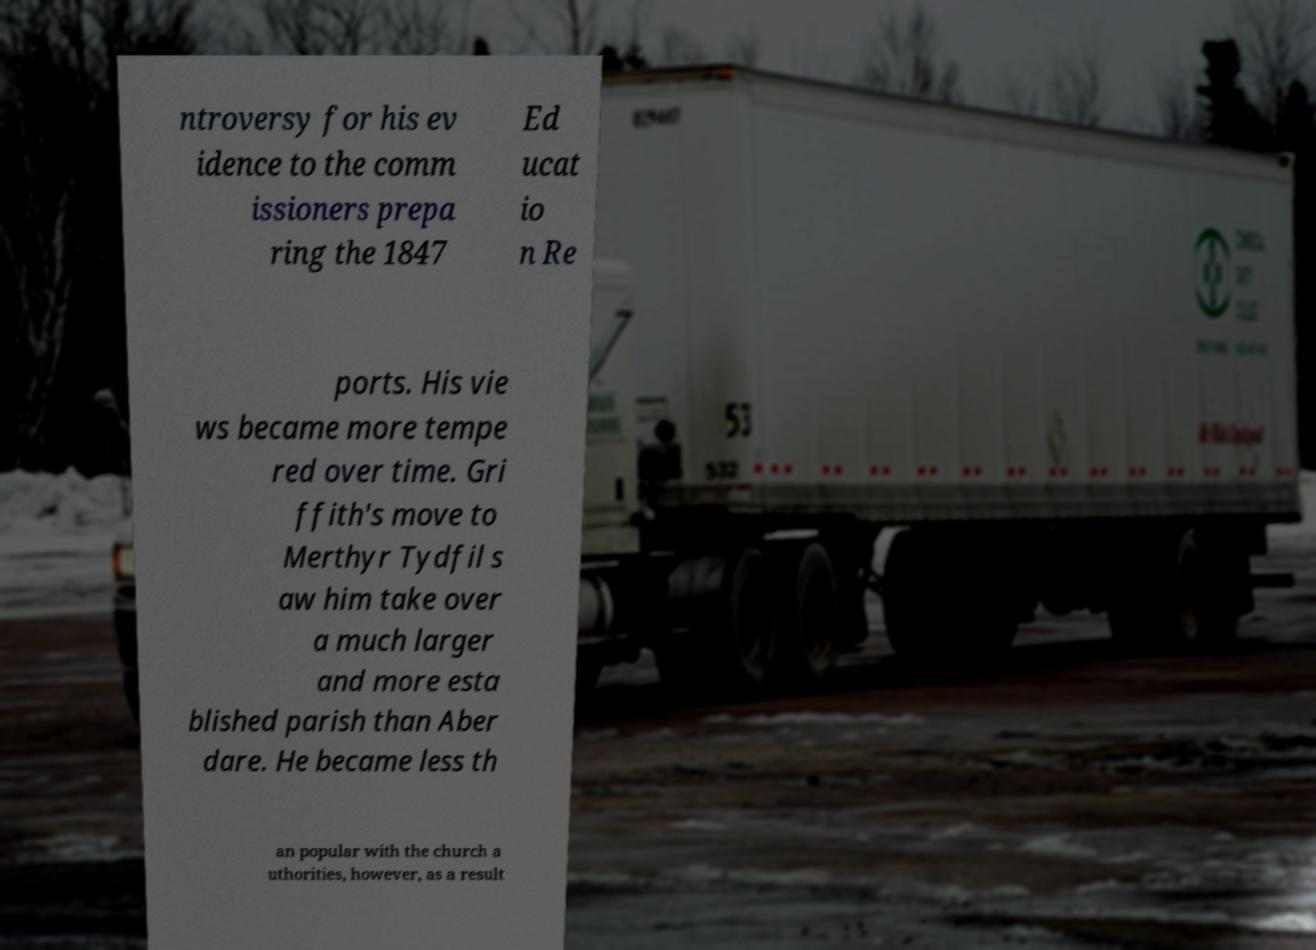There's text embedded in this image that I need extracted. Can you transcribe it verbatim? ntroversy for his ev idence to the comm issioners prepa ring the 1847 Ed ucat io n Re ports. His vie ws became more tempe red over time. Gri ffith's move to Merthyr Tydfil s aw him take over a much larger and more esta blished parish than Aber dare. He became less th an popular with the church a uthorities, however, as a result 